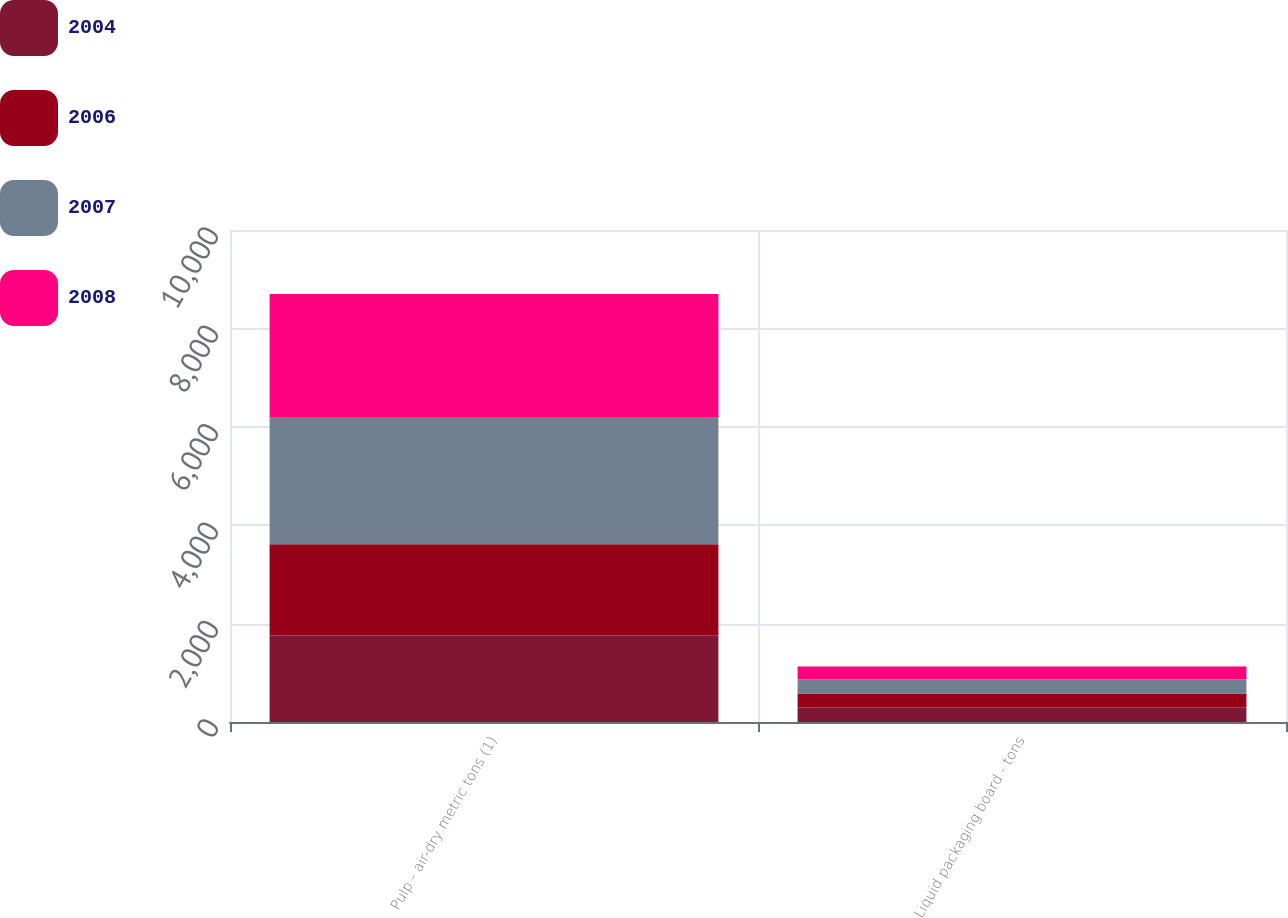Convert chart. <chart><loc_0><loc_0><loc_500><loc_500><stacked_bar_chart><ecel><fcel>Pulp - air-dry metric tons (1)<fcel>Liquid packaging board - tons<nl><fcel>2004<fcel>1760<fcel>297<nl><fcel>2006<fcel>1851<fcel>283<nl><fcel>2007<fcel>2588<fcel>282<nl><fcel>2008<fcel>2502<fcel>264<nl></chart> 